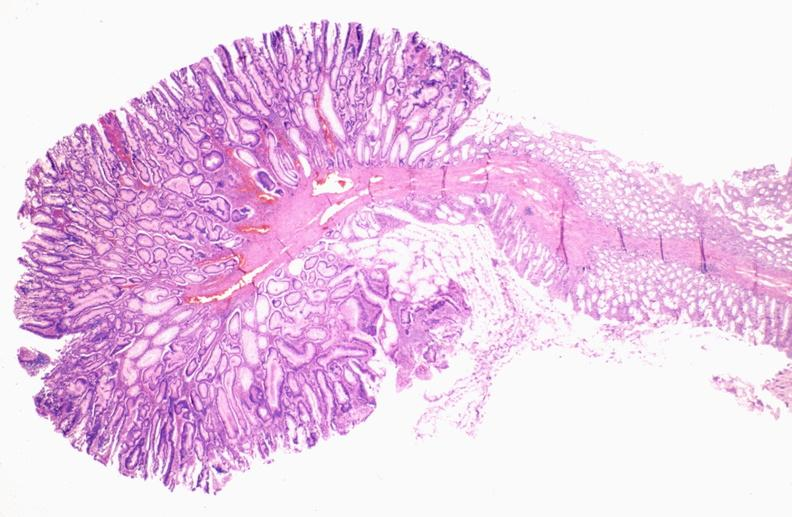s papillary intraductal adenocarcinoma present?
Answer the question using a single word or phrase. No 